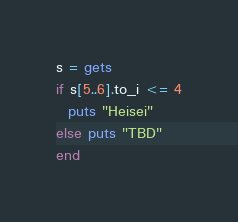Convert code to text. <code><loc_0><loc_0><loc_500><loc_500><_Ruby_>s = gets
if s[5..6].to_i <= 4
  puts "Heisei"
else puts "TBD"
end
</code> 